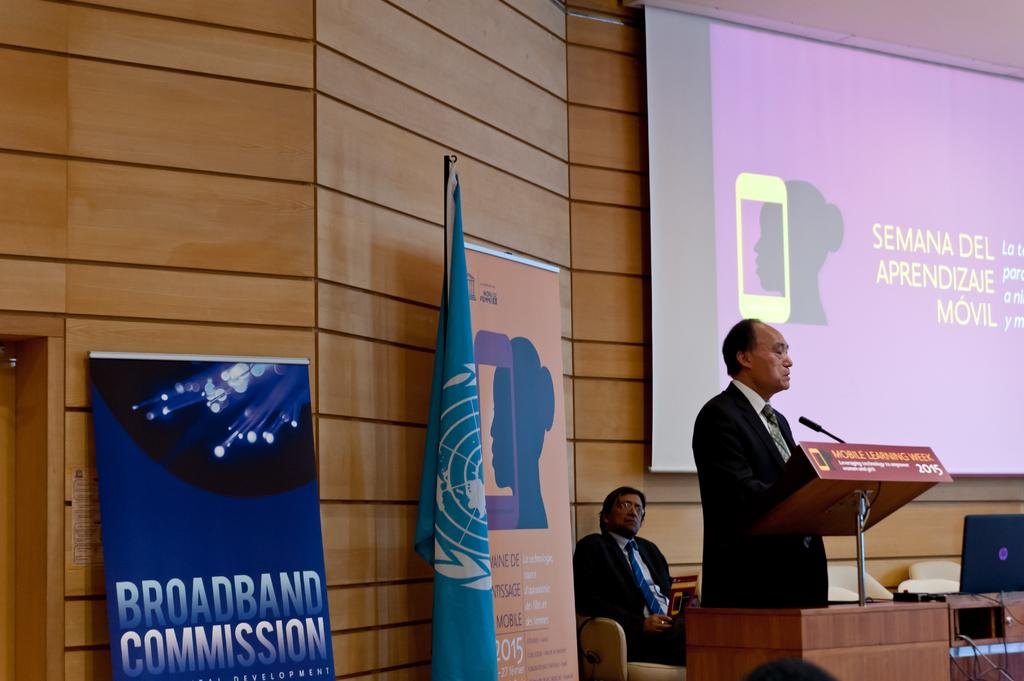What is the person near the speaker stand holding? The person is holding a mic. What can be seen on the wall in the image? There is a board and a flag on the wall in the image. What equipment is present for displaying visuals? There is a projector in the image. What device is being used to control the presentation? There is a laptop in the image. How many chairs are visible in the image? There are chairs in the image. Is there anyone sitting in the image? Yes, there is a person sitting in the image. How many family members are visible in the image? There is no reference to a family or any family members in the image. What type of ground is visible in the image? There is no ground visible in the image; it appears to be an indoor setting. 